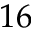Convert formula to latex. <formula><loc_0><loc_0><loc_500><loc_500>1 6</formula> 